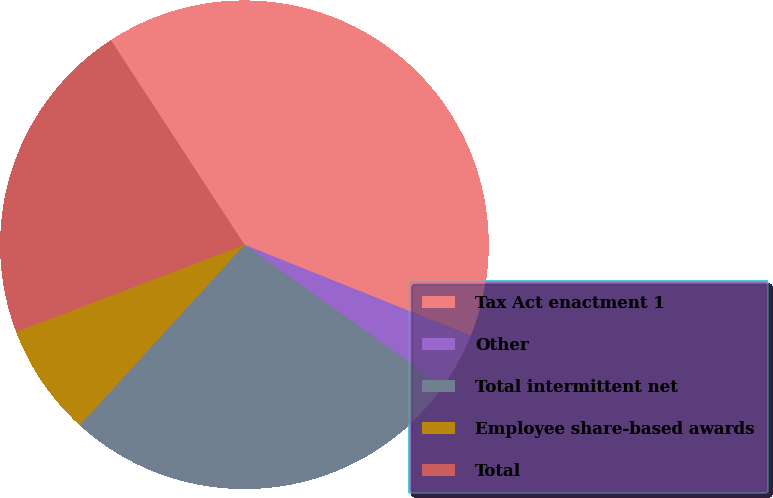Convert chart. <chart><loc_0><loc_0><loc_500><loc_500><pie_chart><fcel>Tax Act enactment 1<fcel>Other<fcel>Total intermittent net<fcel>Employee share-based awards<fcel>Total<nl><fcel>40.29%<fcel>3.77%<fcel>26.92%<fcel>7.42%<fcel>21.6%<nl></chart> 